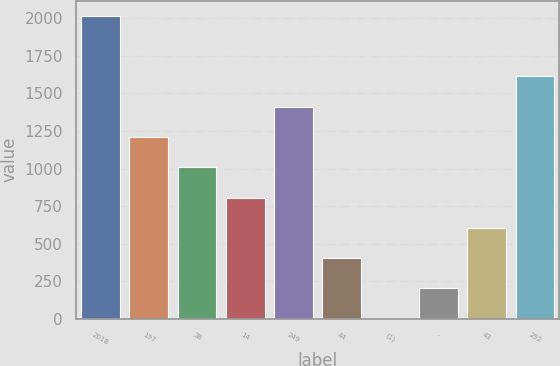Convert chart. <chart><loc_0><loc_0><loc_500><loc_500><bar_chart><fcel>2018<fcel>197<fcel>38<fcel>14<fcel>249<fcel>44<fcel>(1)<fcel>-<fcel>43<fcel>292<nl><fcel>2017<fcel>1210.6<fcel>1009<fcel>807.4<fcel>1412.2<fcel>404.2<fcel>1<fcel>202.6<fcel>605.8<fcel>1613.8<nl></chart> 